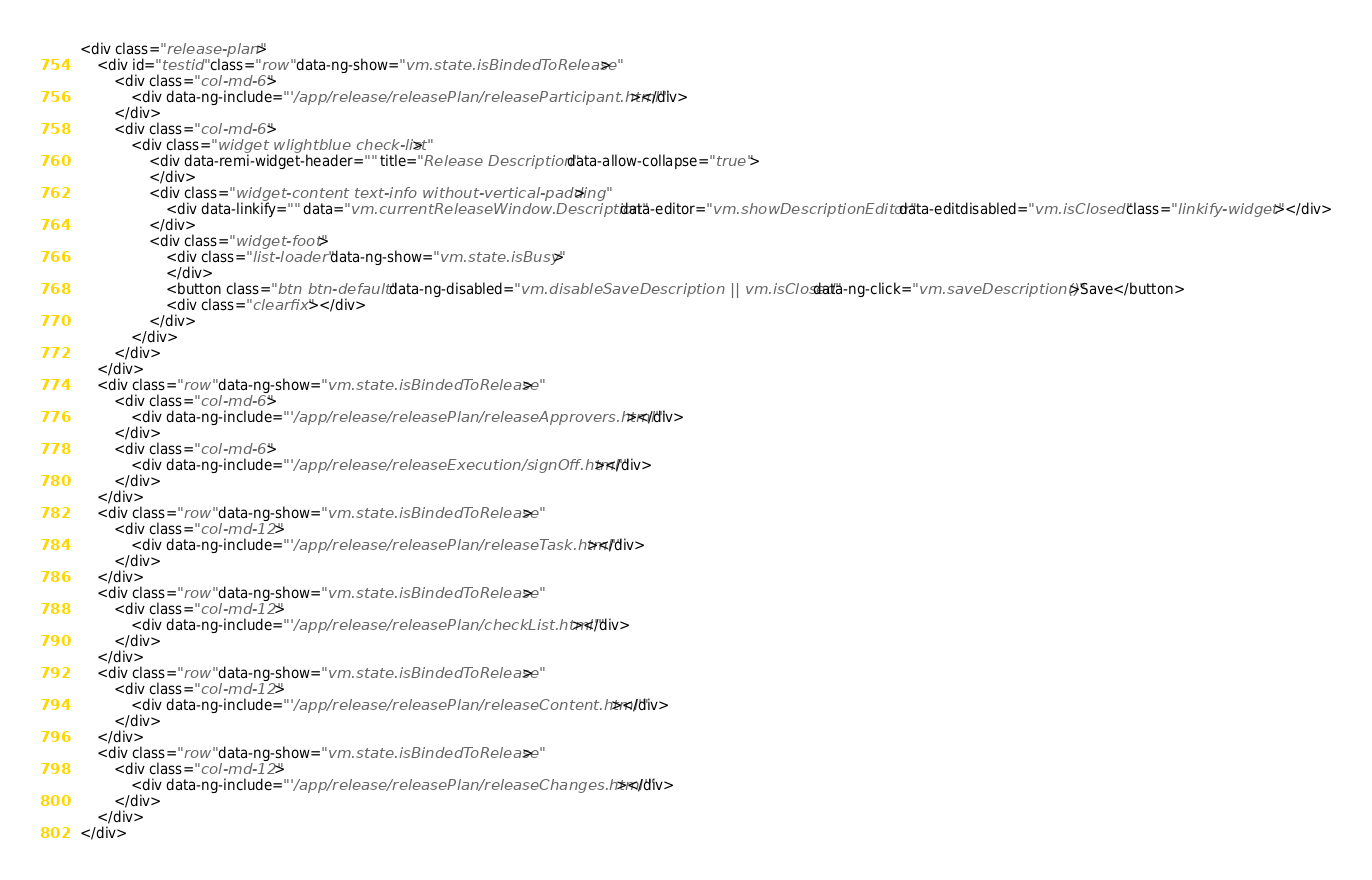Convert code to text. <code><loc_0><loc_0><loc_500><loc_500><_HTML_><div class="release-plan">
    <div id="testid" class="row" data-ng-show="vm.state.isBindedToRelease">
        <div class="col-md-6">
            <div data-ng-include="'/app/release/releasePlan/releaseParticipant.html'"></div>
        </div>
        <div class="col-md-6">
            <div class="widget wlightblue check-list">
                <div data-remi-widget-header="" title="Release Description" data-allow-collapse="true">
                </div>
                <div class="widget-content text-info without-vertical-padding">
                    <div data-linkify="" data="vm.currentReleaseWindow.Description" data-editor="vm.showDescriptionEditor" data-editdisabled="vm.isClosed" class="linkify-widget"></div>
                </div>
                <div class="widget-foot">
                    <div class="list-loader" data-ng-show="vm.state.isBusy">
                    </div>
                    <button class="btn btn-default" data-ng-disabled="vm.disableSaveDescription || vm.isClosed" data-ng-click="vm.saveDescription()">Save</button>
                    <div class="clearfix"></div>
                </div>
            </div>
        </div>
    </div>
    <div class="row" data-ng-show="vm.state.isBindedToRelease">
        <div class="col-md-6">
            <div data-ng-include="'/app/release/releasePlan/releaseApprovers.html'"></div>
        </div>
        <div class="col-md-6">
            <div data-ng-include="'/app/release/releaseExecution/signOff.html'"></div>
        </div>
    </div>
    <div class="row" data-ng-show="vm.state.isBindedToRelease">
        <div class="col-md-12">
            <div data-ng-include="'/app/release/releasePlan/releaseTask.html'"></div>
        </div>
    </div>
    <div class="row" data-ng-show="vm.state.isBindedToRelease">
        <div class="col-md-12">
            <div data-ng-include="'/app/release/releasePlan/checkList.html'"></div>
        </div>
    </div>
    <div class="row" data-ng-show="vm.state.isBindedToRelease">
        <div class="col-md-12">
            <div data-ng-include="'/app/release/releasePlan/releaseContent.html'"></div>
        </div>
    </div>
    <div class="row" data-ng-show="vm.state.isBindedToRelease">
        <div class="col-md-12">
            <div data-ng-include="'/app/release/releasePlan/releaseChanges.html'"></div>
        </div>
    </div>
</div>
</code> 